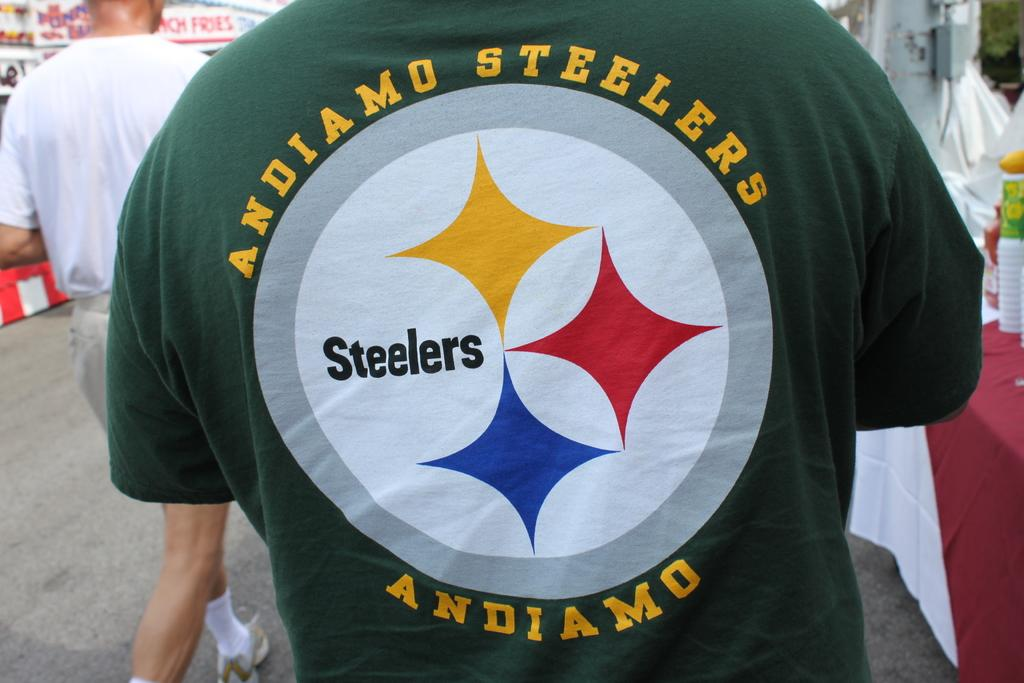<image>
Present a compact description of the photo's key features. A Steelers logo can be seen on the back of a shirt. 